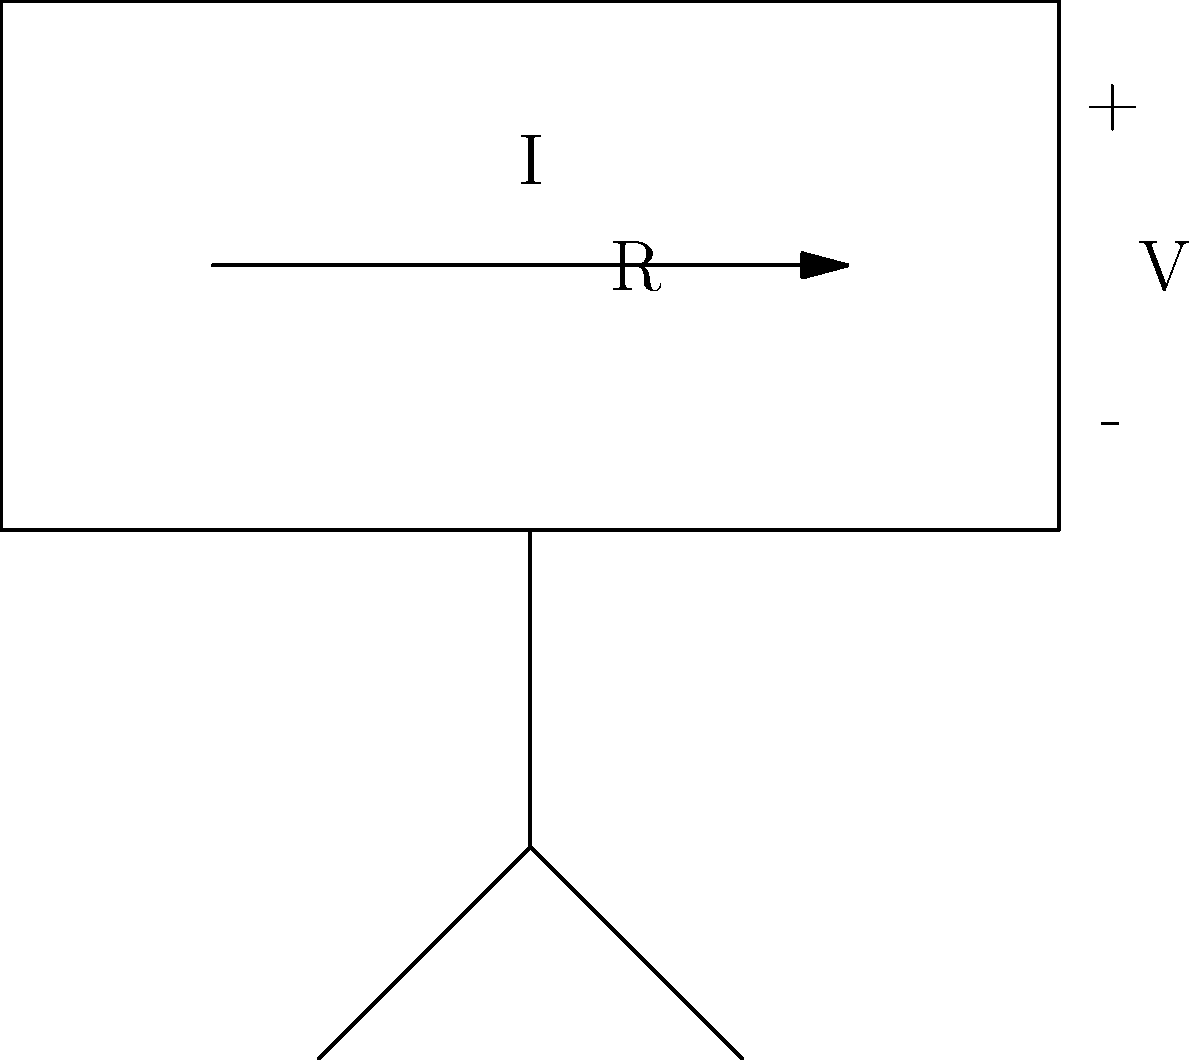In the simple circuit diagram shown above, which represents a basic component of many digital devices, what happens to the current (I) if the resistance (R) is increased while the voltage (V) remains constant? To understand what happens to the current when resistance increases and voltage remains constant, we need to follow these steps:

1. Recall Ohm's Law: This fundamental law of electrical circuits states that $V = IR$, where V is voltage, I is current, and R is resistance.

2. Rearrange Ohm's Law: We can rewrite the equation as $I = \frac{V}{R}$ to solve for current.

3. Analyze the given information:
   - Voltage (V) remains constant
   - Resistance (R) is increased

4. Apply the relationship:
   - If R increases and V is constant, the fraction $\frac{V}{R}$ will decrease.
   - Since $I = \frac{V}{R}$, a decrease in this fraction means a decrease in current.

5. Consider the physical interpretation:
   - Increased resistance means the circuit opposes the flow of electrons more strongly.
   - With the same "pushing force" (voltage) and more opposition (resistance), fewer electrons can flow through the circuit per unit time.

Therefore, when resistance increases and voltage remains constant, the current in the circuit will decrease.
Answer: Current decreases 